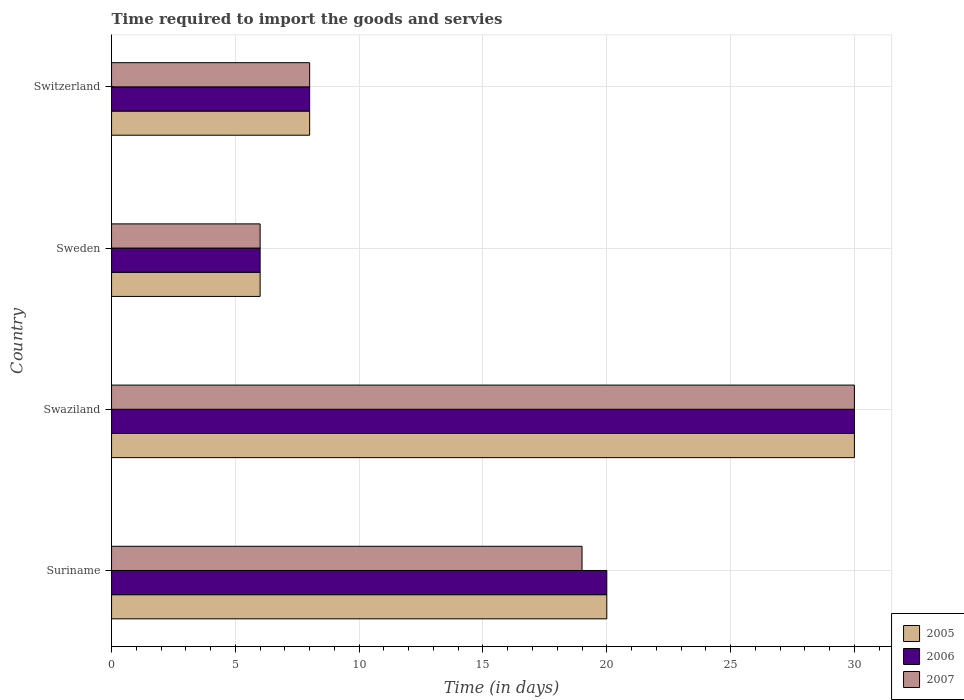How many different coloured bars are there?
Your answer should be very brief. 3. Are the number of bars per tick equal to the number of legend labels?
Your response must be concise. Yes. How many bars are there on the 2nd tick from the top?
Provide a short and direct response. 3. What is the label of the 4th group of bars from the top?
Keep it short and to the point. Suriname. In how many cases, is the number of bars for a given country not equal to the number of legend labels?
Keep it short and to the point. 0. What is the number of days required to import the goods and services in 2007 in Swaziland?
Your response must be concise. 30. Across all countries, what is the minimum number of days required to import the goods and services in 2005?
Make the answer very short. 6. In which country was the number of days required to import the goods and services in 2007 maximum?
Your answer should be very brief. Swaziland. In which country was the number of days required to import the goods and services in 2006 minimum?
Give a very brief answer. Sweden. What is the difference between the number of days required to import the goods and services in 2007 in Switzerland and the number of days required to import the goods and services in 2006 in Swaziland?
Provide a succinct answer. -22. What is the average number of days required to import the goods and services in 2007 per country?
Provide a short and direct response. 15.75. What is the difference between the number of days required to import the goods and services in 2005 and number of days required to import the goods and services in 2007 in Switzerland?
Give a very brief answer. 0. In how many countries, is the number of days required to import the goods and services in 2005 greater than 26 days?
Give a very brief answer. 1. What is the ratio of the number of days required to import the goods and services in 2007 in Suriname to that in Sweden?
Provide a succinct answer. 3.17. What is the difference between the highest and the lowest number of days required to import the goods and services in 2007?
Your answer should be very brief. 24. What does the 3rd bar from the top in Sweden represents?
Provide a short and direct response. 2005. What does the 2nd bar from the bottom in Sweden represents?
Ensure brevity in your answer.  2006. Is it the case that in every country, the sum of the number of days required to import the goods and services in 2006 and number of days required to import the goods and services in 2007 is greater than the number of days required to import the goods and services in 2005?
Offer a terse response. Yes. How many bars are there?
Provide a short and direct response. 12. How many countries are there in the graph?
Keep it short and to the point. 4. What is the title of the graph?
Your response must be concise. Time required to import the goods and servies. Does "1984" appear as one of the legend labels in the graph?
Keep it short and to the point. No. What is the label or title of the X-axis?
Your answer should be very brief. Time (in days). What is the label or title of the Y-axis?
Your answer should be very brief. Country. What is the Time (in days) of 2007 in Suriname?
Give a very brief answer. 19. What is the Time (in days) in 2006 in Swaziland?
Give a very brief answer. 30. What is the Time (in days) of 2006 in Sweden?
Offer a terse response. 6. What is the Time (in days) in 2006 in Switzerland?
Offer a terse response. 8. Across all countries, what is the maximum Time (in days) of 2006?
Make the answer very short. 30. Across all countries, what is the maximum Time (in days) of 2007?
Ensure brevity in your answer.  30. Across all countries, what is the minimum Time (in days) of 2006?
Ensure brevity in your answer.  6. Across all countries, what is the minimum Time (in days) in 2007?
Provide a short and direct response. 6. What is the total Time (in days) of 2006 in the graph?
Make the answer very short. 64. What is the difference between the Time (in days) in 2007 in Suriname and that in Swaziland?
Ensure brevity in your answer.  -11. What is the difference between the Time (in days) in 2005 in Suriname and that in Sweden?
Ensure brevity in your answer.  14. What is the difference between the Time (in days) in 2006 in Suriname and that in Sweden?
Your answer should be compact. 14. What is the difference between the Time (in days) in 2005 in Swaziland and that in Sweden?
Give a very brief answer. 24. What is the difference between the Time (in days) of 2007 in Sweden and that in Switzerland?
Offer a terse response. -2. What is the difference between the Time (in days) in 2005 in Suriname and the Time (in days) in 2007 in Swaziland?
Your answer should be compact. -10. What is the difference between the Time (in days) of 2006 in Suriname and the Time (in days) of 2007 in Swaziland?
Keep it short and to the point. -10. What is the difference between the Time (in days) of 2005 in Suriname and the Time (in days) of 2007 in Sweden?
Make the answer very short. 14. What is the difference between the Time (in days) of 2005 in Suriname and the Time (in days) of 2006 in Switzerland?
Your answer should be very brief. 12. What is the difference between the Time (in days) in 2005 in Suriname and the Time (in days) in 2007 in Switzerland?
Your answer should be compact. 12. What is the difference between the Time (in days) in 2005 in Swaziland and the Time (in days) in 2006 in Sweden?
Give a very brief answer. 24. What is the difference between the Time (in days) of 2005 in Swaziland and the Time (in days) of 2007 in Sweden?
Ensure brevity in your answer.  24. What is the difference between the Time (in days) in 2006 in Swaziland and the Time (in days) in 2007 in Sweden?
Ensure brevity in your answer.  24. What is the difference between the Time (in days) of 2005 in Swaziland and the Time (in days) of 2007 in Switzerland?
Your response must be concise. 22. What is the difference between the Time (in days) in 2005 in Sweden and the Time (in days) in 2006 in Switzerland?
Offer a terse response. -2. What is the difference between the Time (in days) in 2006 in Sweden and the Time (in days) in 2007 in Switzerland?
Offer a terse response. -2. What is the average Time (in days) of 2005 per country?
Make the answer very short. 16. What is the average Time (in days) of 2006 per country?
Offer a very short reply. 16. What is the average Time (in days) of 2007 per country?
Provide a succinct answer. 15.75. What is the difference between the Time (in days) of 2006 and Time (in days) of 2007 in Suriname?
Keep it short and to the point. 1. What is the difference between the Time (in days) in 2005 and Time (in days) in 2006 in Swaziland?
Offer a terse response. 0. What is the difference between the Time (in days) of 2006 and Time (in days) of 2007 in Swaziland?
Provide a short and direct response. 0. What is the difference between the Time (in days) in 2005 and Time (in days) in 2006 in Sweden?
Offer a very short reply. 0. What is the difference between the Time (in days) of 2005 and Time (in days) of 2006 in Switzerland?
Provide a succinct answer. 0. What is the difference between the Time (in days) of 2005 and Time (in days) of 2007 in Switzerland?
Provide a succinct answer. 0. What is the ratio of the Time (in days) of 2005 in Suriname to that in Swaziland?
Provide a short and direct response. 0.67. What is the ratio of the Time (in days) of 2006 in Suriname to that in Swaziland?
Ensure brevity in your answer.  0.67. What is the ratio of the Time (in days) of 2007 in Suriname to that in Swaziland?
Provide a short and direct response. 0.63. What is the ratio of the Time (in days) in 2007 in Suriname to that in Sweden?
Offer a very short reply. 3.17. What is the ratio of the Time (in days) of 2005 in Suriname to that in Switzerland?
Your response must be concise. 2.5. What is the ratio of the Time (in days) of 2006 in Suriname to that in Switzerland?
Your answer should be very brief. 2.5. What is the ratio of the Time (in days) in 2007 in Suriname to that in Switzerland?
Offer a terse response. 2.38. What is the ratio of the Time (in days) in 2006 in Swaziland to that in Sweden?
Ensure brevity in your answer.  5. What is the ratio of the Time (in days) of 2005 in Swaziland to that in Switzerland?
Offer a very short reply. 3.75. What is the ratio of the Time (in days) of 2006 in Swaziland to that in Switzerland?
Your response must be concise. 3.75. What is the ratio of the Time (in days) of 2007 in Swaziland to that in Switzerland?
Your answer should be very brief. 3.75. What is the ratio of the Time (in days) in 2005 in Sweden to that in Switzerland?
Give a very brief answer. 0.75. What is the ratio of the Time (in days) in 2007 in Sweden to that in Switzerland?
Your answer should be compact. 0.75. What is the difference between the highest and the second highest Time (in days) in 2006?
Provide a succinct answer. 10. What is the difference between the highest and the second highest Time (in days) of 2007?
Provide a succinct answer. 11. What is the difference between the highest and the lowest Time (in days) in 2005?
Your answer should be very brief. 24. What is the difference between the highest and the lowest Time (in days) of 2006?
Provide a short and direct response. 24. What is the difference between the highest and the lowest Time (in days) of 2007?
Give a very brief answer. 24. 